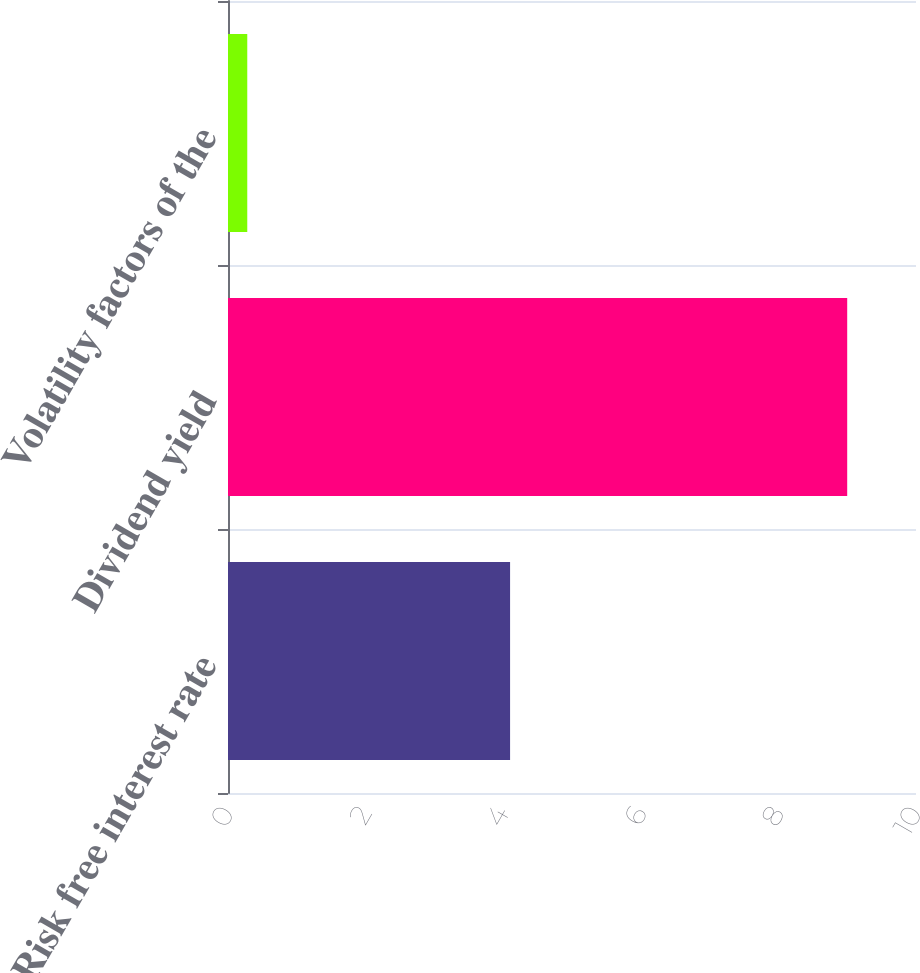Convert chart. <chart><loc_0><loc_0><loc_500><loc_500><bar_chart><fcel>Risk free interest rate<fcel>Dividend yield<fcel>Volatility factors of the<nl><fcel>4.1<fcel>9<fcel>0.28<nl></chart> 